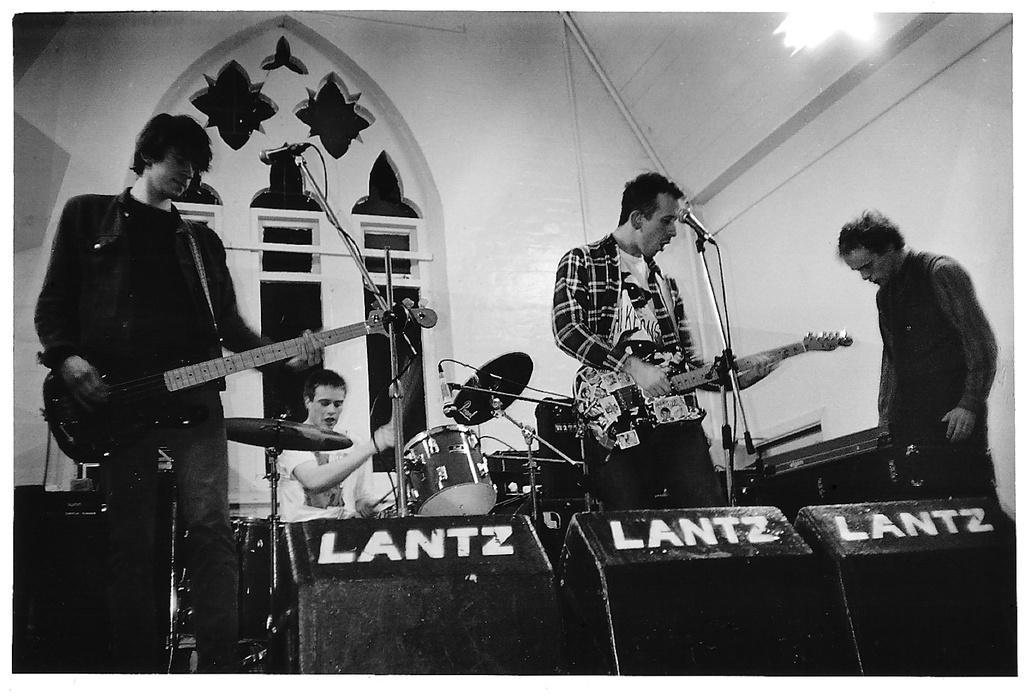Please provide a concise description of this image. There are 3 persons are standing. They are playing a musical instruments. In the center of the person is sitting on a chair. He is playing a musical drum. We can see in the background arch,wall and light. 